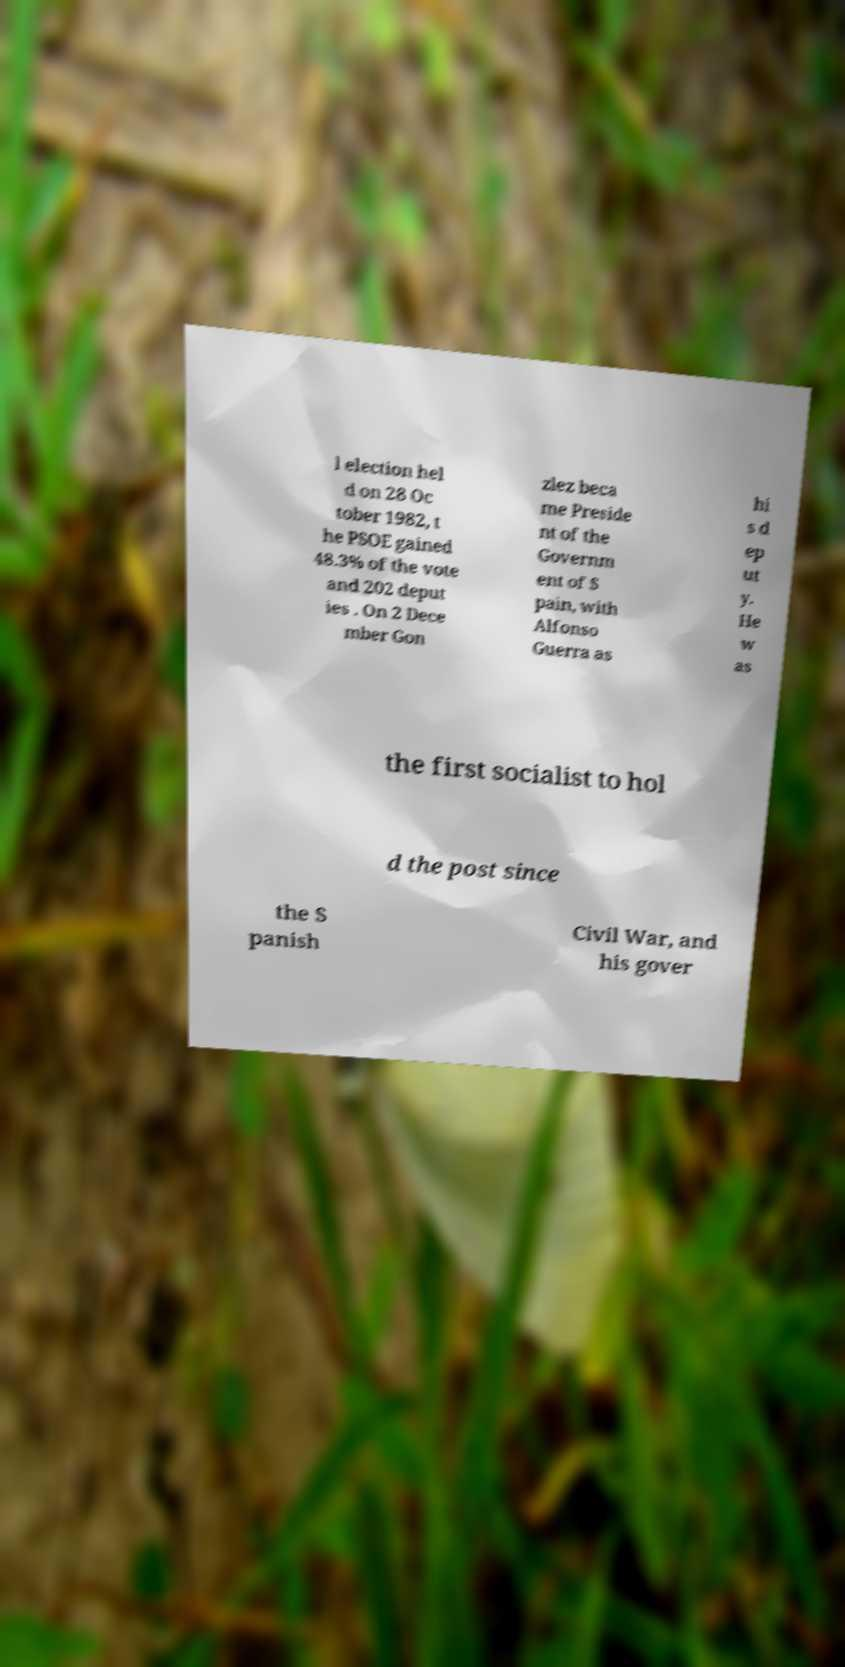I need the written content from this picture converted into text. Can you do that? l election hel d on 28 Oc tober 1982, t he PSOE gained 48.3% of the vote and 202 deput ies . On 2 Dece mber Gon zlez beca me Preside nt of the Governm ent of S pain, with Alfonso Guerra as hi s d ep ut y. He w as the first socialist to hol d the post since the S panish Civil War, and his gover 